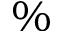<formula> <loc_0><loc_0><loc_500><loc_500>\%</formula> 